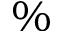<formula> <loc_0><loc_0><loc_500><loc_500>\%</formula> 